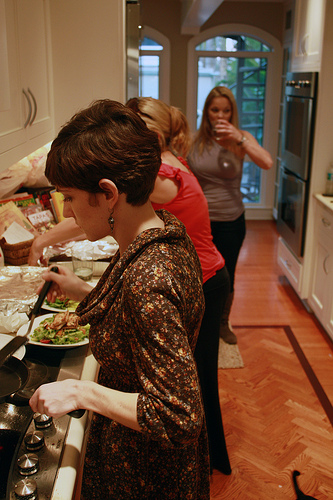Please provide the bounding box coordinate of the region this sentence describes: a double oven in the wall. [0.72, 0.14, 0.8, 0.52]. This area includes the double oven built into the wall of the kitchen. 